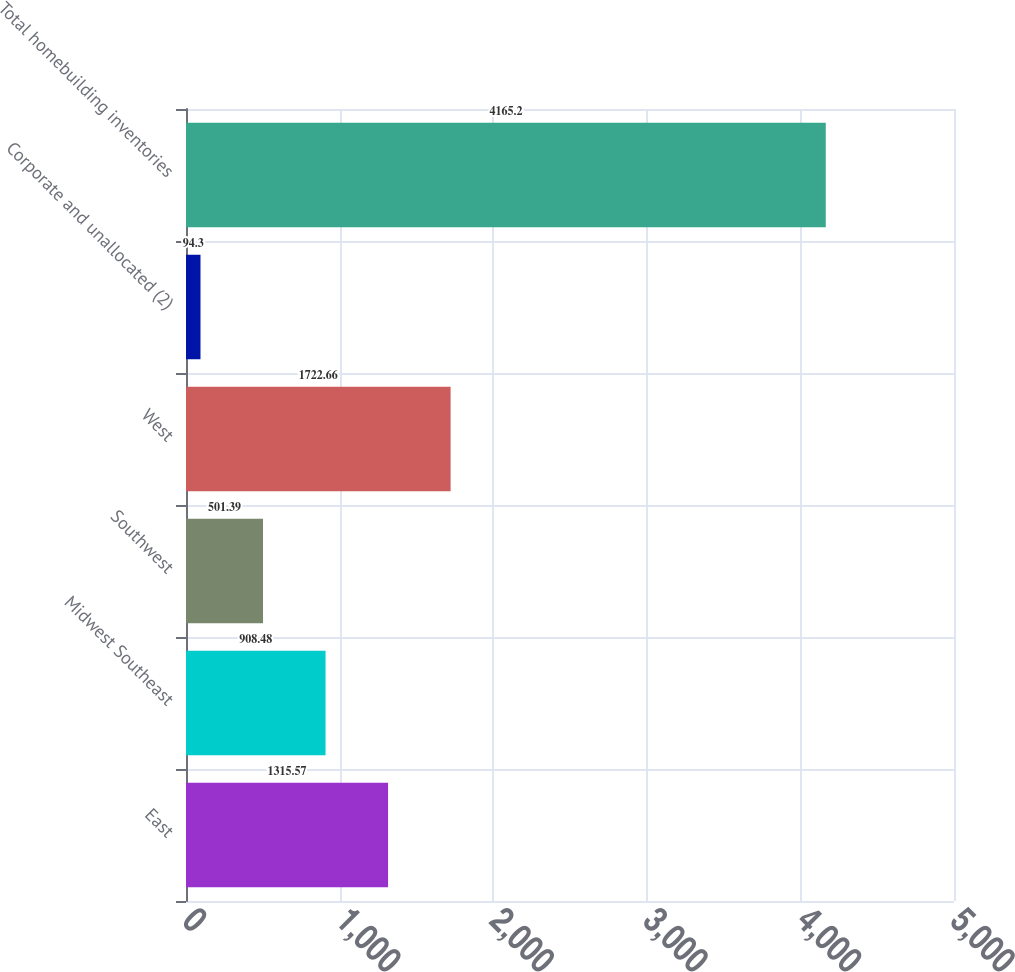Convert chart to OTSL. <chart><loc_0><loc_0><loc_500><loc_500><bar_chart><fcel>East<fcel>Midwest Southeast<fcel>Southwest<fcel>West<fcel>Corporate and unallocated (2)<fcel>Total homebuilding inventories<nl><fcel>1315.57<fcel>908.48<fcel>501.39<fcel>1722.66<fcel>94.3<fcel>4165.2<nl></chart> 